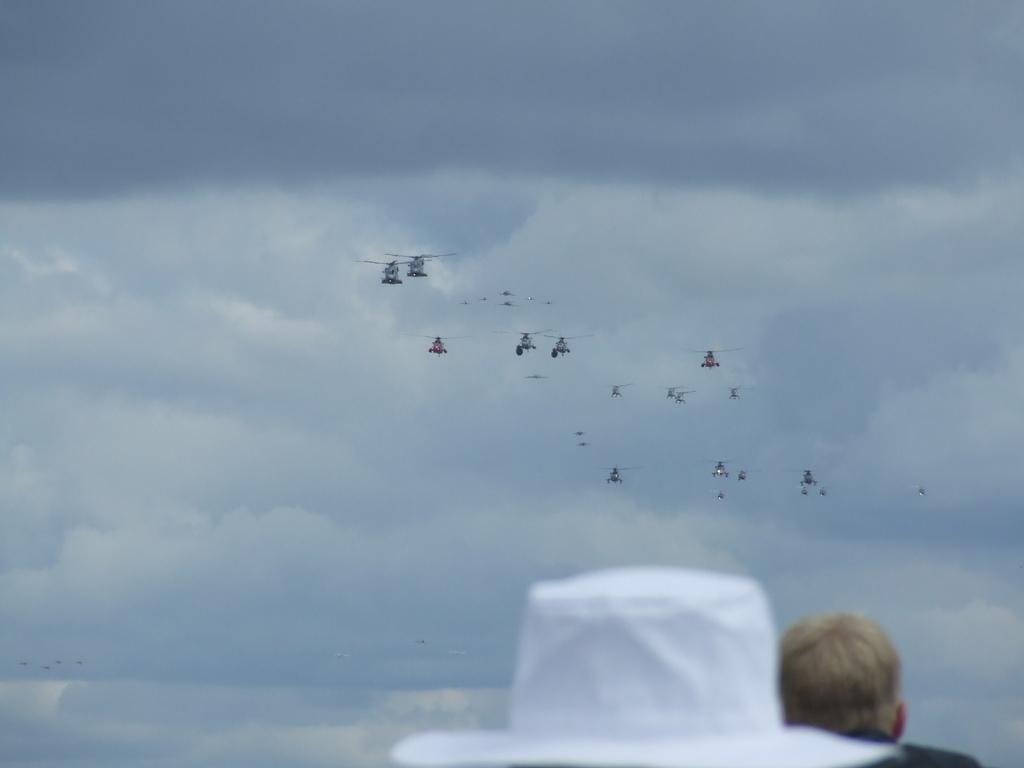In one or two sentences, can you explain what this image depicts? To the down we can see a white hat and another person and there are many flights flying. In the background there is sky with clouds. 